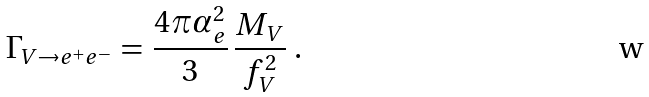<formula> <loc_0><loc_0><loc_500><loc_500>\Gamma _ { V \rightarrow e ^ { + } e ^ { - } } \, = \, \frac { 4 \pi \alpha _ { e } ^ { 2 } } { 3 } \, \frac { M _ { V } } { f _ { V } ^ { 2 } } \ .</formula> 